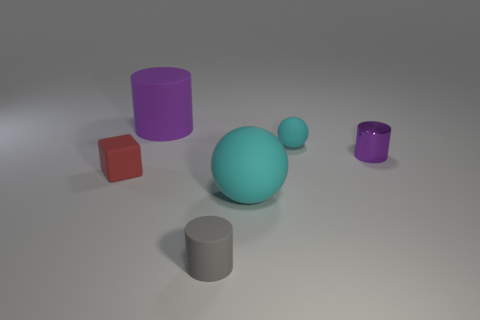Subtract all large cylinders. How many cylinders are left? 2 Add 4 big cyan balls. How many objects exist? 10 Subtract all balls. How many objects are left? 4 Subtract all small cubes. Subtract all big purple objects. How many objects are left? 4 Add 1 spheres. How many spheres are left? 3 Add 1 yellow rubber blocks. How many yellow rubber blocks exist? 1 Subtract 0 green cylinders. How many objects are left? 6 